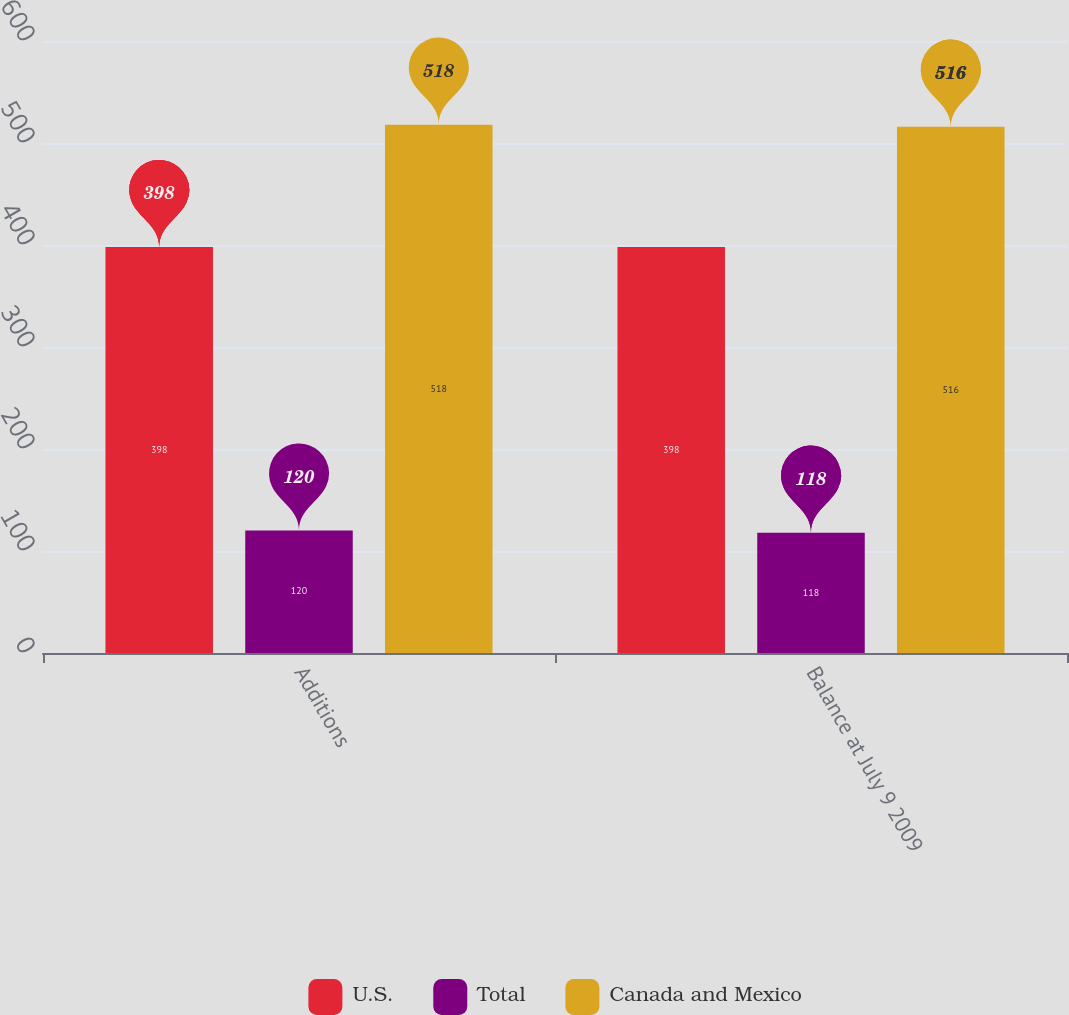Convert chart to OTSL. <chart><loc_0><loc_0><loc_500><loc_500><stacked_bar_chart><ecel><fcel>Additions<fcel>Balance at July 9 2009<nl><fcel>U.S.<fcel>398<fcel>398<nl><fcel>Total<fcel>120<fcel>118<nl><fcel>Canada and Mexico<fcel>518<fcel>516<nl></chart> 